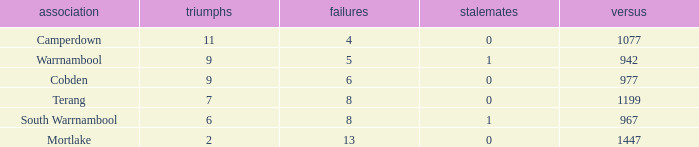What is the draw when the losses were more than 8 and less than 2 wins? None. 